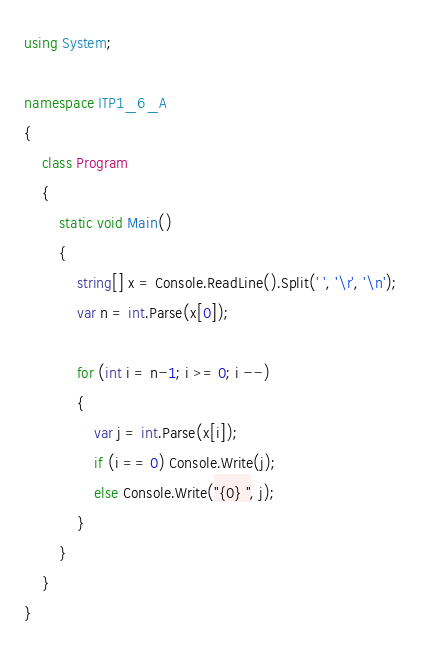Convert code to text. <code><loc_0><loc_0><loc_500><loc_500><_C#_>using System;

namespace ITP1_6_A
{
    class Program
    {
        static void Main()
        {
            string[] x = Console.ReadLine().Split(' ', '\r', '\n');
            var n = int.Parse(x[0]);
            
            for (int i = n-1; i >= 0; i --)
            {
                var j = int.Parse(x[i]);
                if (i == 0) Console.Write(j);
                else Console.Write("{0} ", j);
            }
        }
    }
}
</code> 